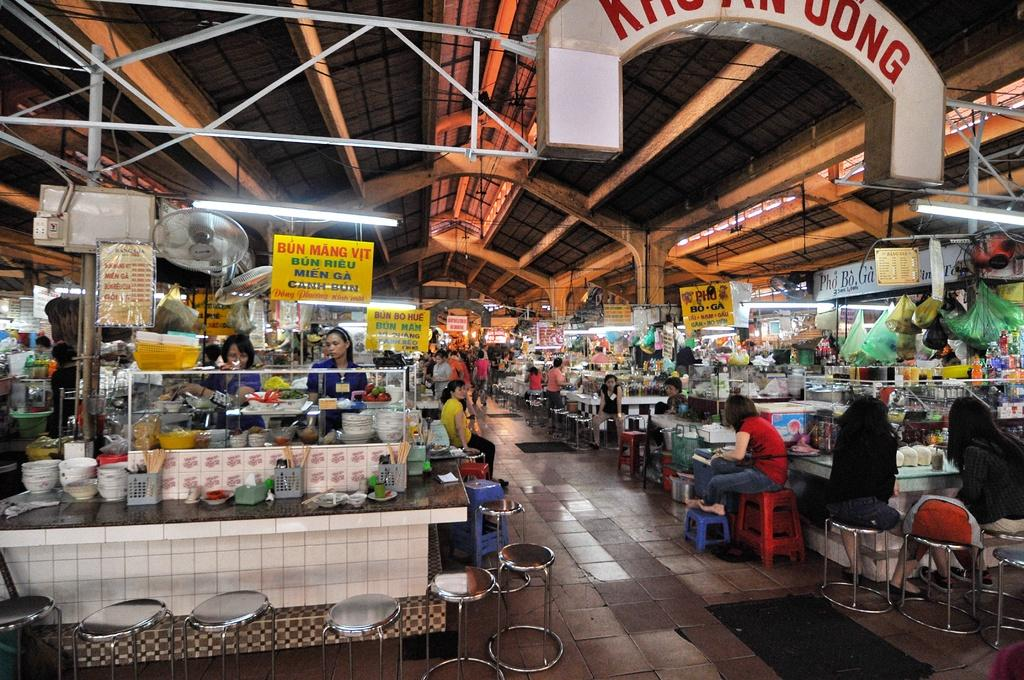<image>
Present a compact description of the photo's key features. A market with several stalls and the yellow sign high on the left says Bun Mang Vit. 